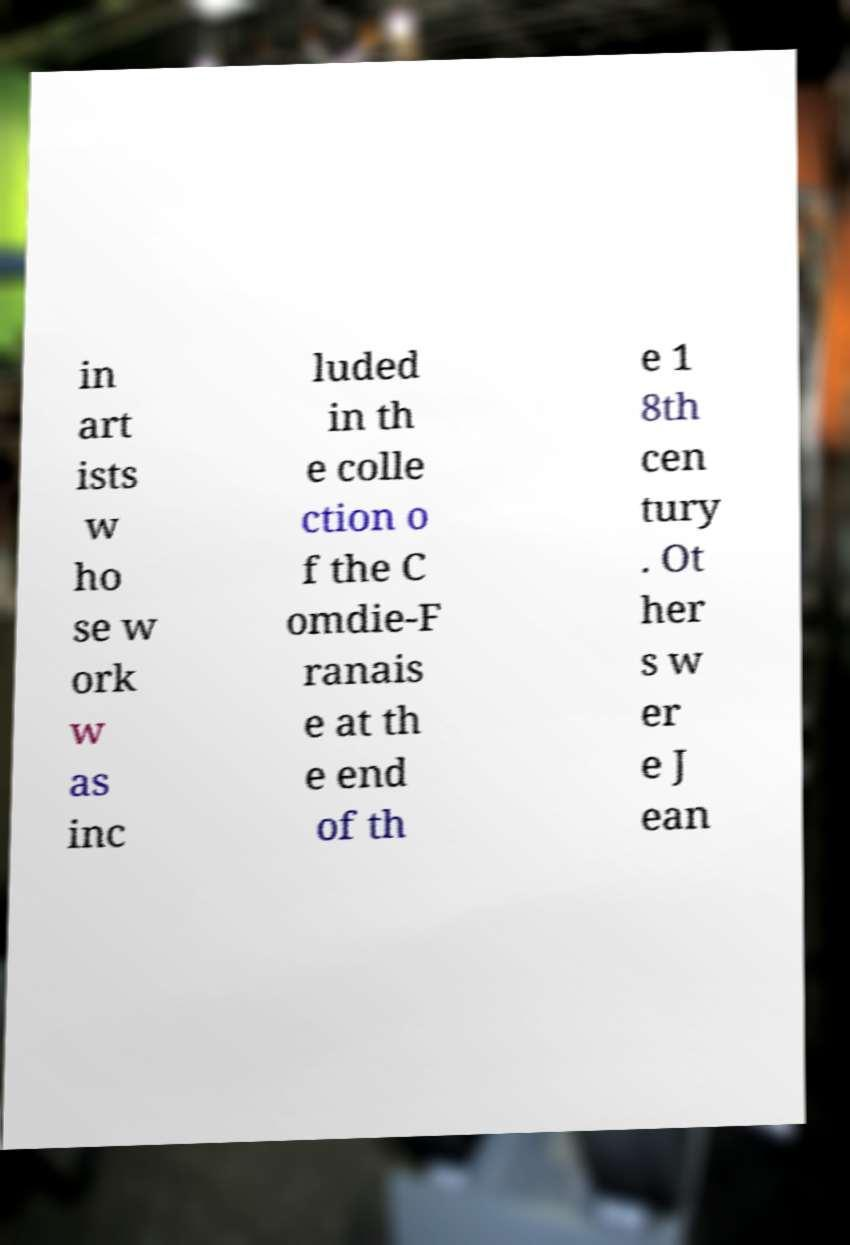What messages or text are displayed in this image? I need them in a readable, typed format. in art ists w ho se w ork w as inc luded in th e colle ction o f the C omdie-F ranais e at th e end of th e 1 8th cen tury . Ot her s w er e J ean 